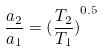Convert formula to latex. <formula><loc_0><loc_0><loc_500><loc_500>\frac { a _ { 2 } } { a _ { 1 } } = { ( \frac { T _ { 2 } } { T _ { 1 } } ) } ^ { 0 . 5 }</formula> 